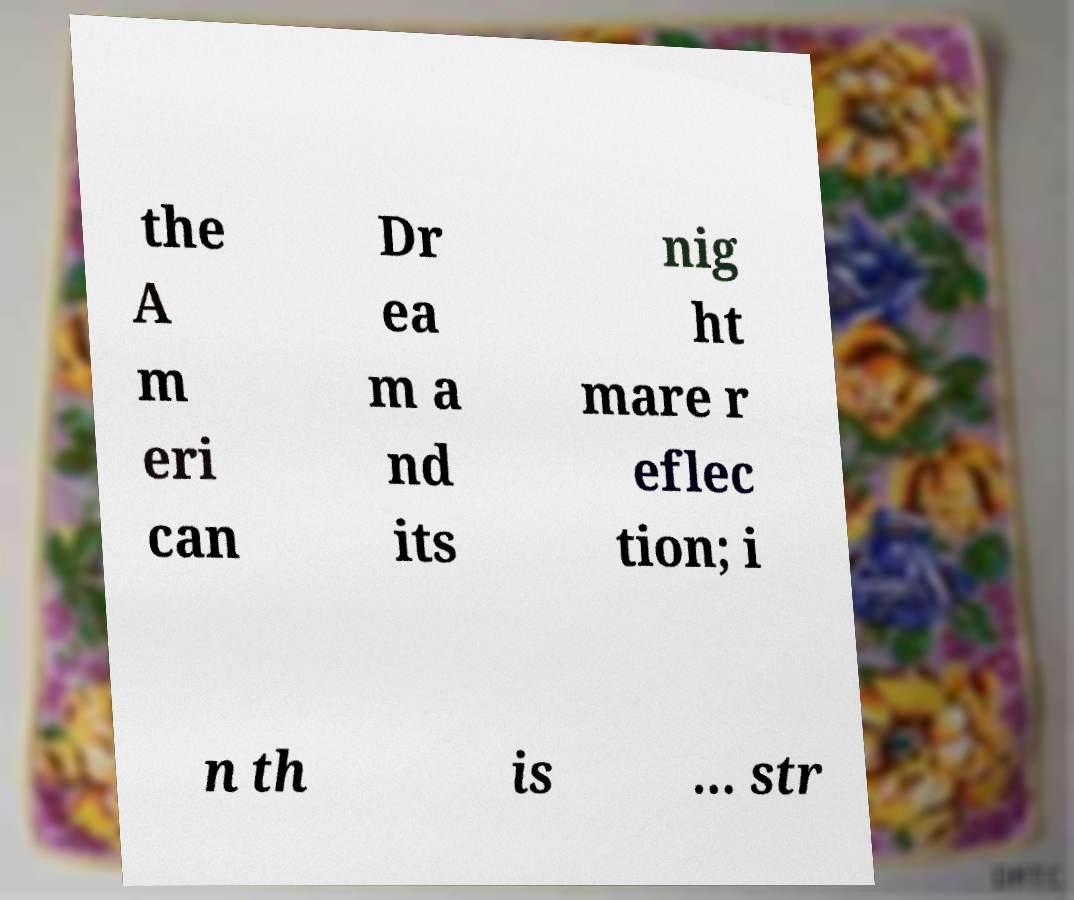Please identify and transcribe the text found in this image. the A m eri can Dr ea m a nd its nig ht mare r eflec tion; i n th is ... str 